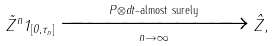Convert formula to latex. <formula><loc_0><loc_0><loc_500><loc_500>\tilde { Z } ^ { n } 1 _ { [ 0 , \tau _ { n } ] } \xrightarrow [ n \rightarrow \infty ] { P \otimes d t \text {-almost surely} } \hat { Z } ,</formula> 